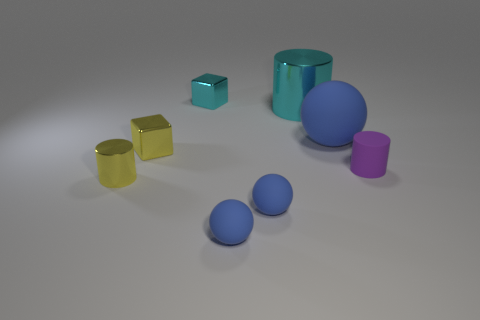How many blue spheres must be subtracted to get 1 blue spheres? 2 Add 1 large balls. How many objects exist? 9 Subtract all blocks. How many objects are left? 6 Add 1 big blue objects. How many big blue objects exist? 2 Subtract 0 brown balls. How many objects are left? 8 Subtract all tiny matte cylinders. Subtract all big blue spheres. How many objects are left? 6 Add 7 small matte spheres. How many small matte spheres are left? 9 